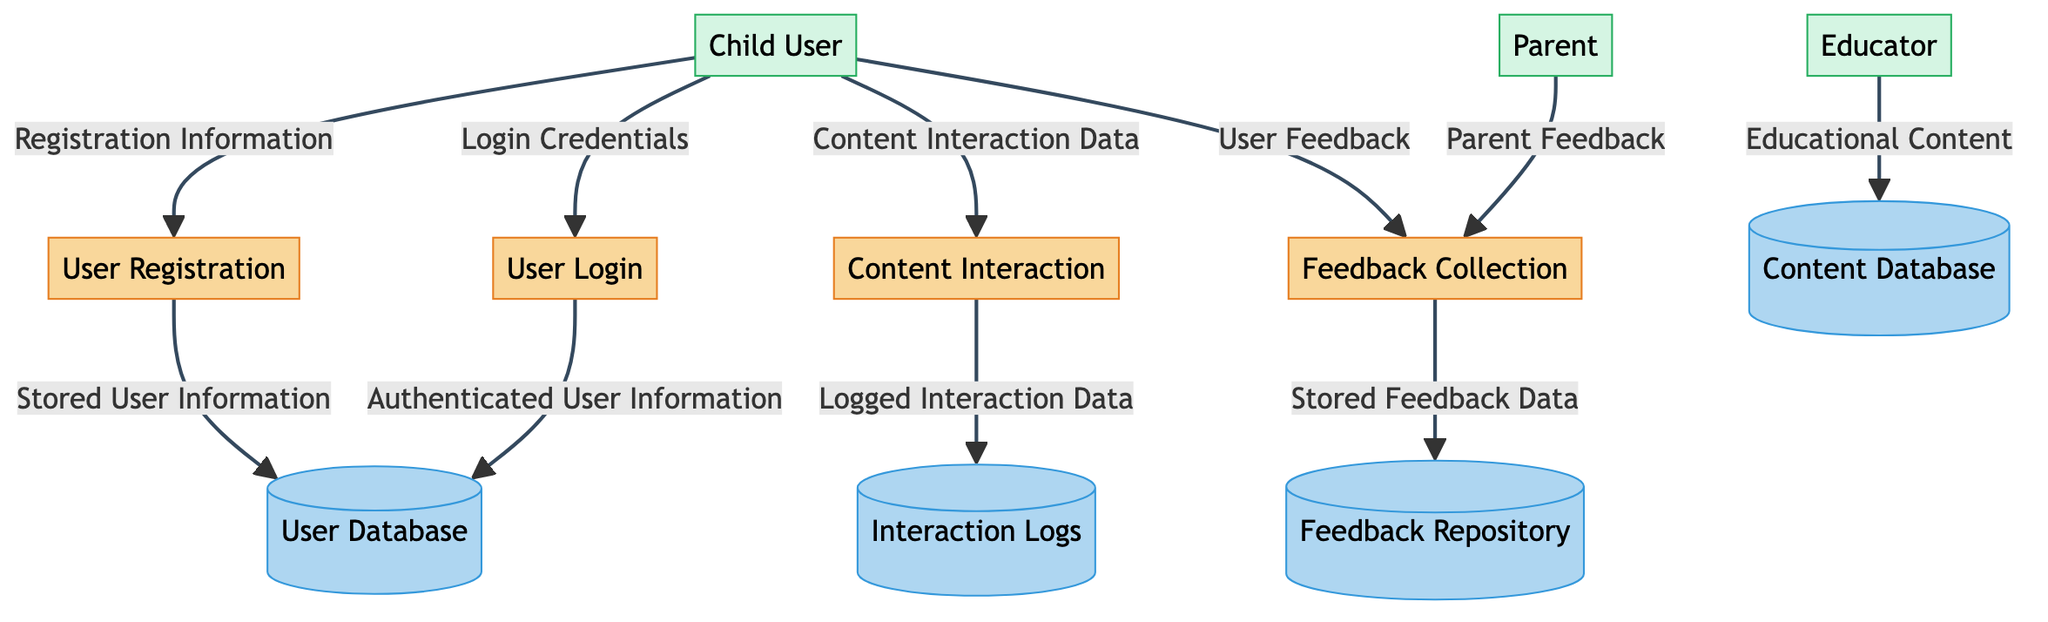What process handles account creation? The process for handling account creation is labeled as "User Registration" in the diagram.
Answer: User Registration How many data stores are present in the diagram? By counting the labeled data stores in the diagram, there are four: User Database, Content Database, Interaction Logs, and Feedback Repository.
Answer: Four What kind of data does the "Content Interaction" process facilitate? The "Content Interaction" process facilitates interaction with educational content and tracks user progress as indicated in the description.
Answer: Educational content interaction Which external entity contributes to content creation? The external entity that contributes to content creation is labeled as "Educator".
Answer: Educator What is stored in the Feedback Repository? The Feedback Repository stores feedback data from users on various aspects of the app according to the data description.
Answer: Feedback data What information does the "User Login" process manage? The "User Login" process manages user authentication and session handling as stated in its description.
Answer: User authentication How does the "User Registration" process interact with the "User Database"? The "User Registration" process sends "Stored User Information" to the "User Database," indicating that it saves the user information after registration.
Answer: Stored User Information What type of feedback is collected from parents? The type of feedback collected from parents is labeled as "Parent Feedback" in the diagram, highlighting their role in providing insights on app usage.
Answer: Parent Feedback Which data flow originates from the "Child User"? The "Child User" sends multiple flows: "Registration Information," "Login Credentials," "Content Interaction Data," and "User Feedback," showing their various interactions with the app.
Answer: Registration Information, Login Credentials, Content Interaction Data, User Feedback What is the relationship between "Feedback Collection" and "Feedback Repository"? The relationship is that "Feedback Collection" sends "Stored Feedback Data" to the "Feedback Repository," indicating that feedback gathered is stored for future analysis.
Answer: Stored Feedback Data 